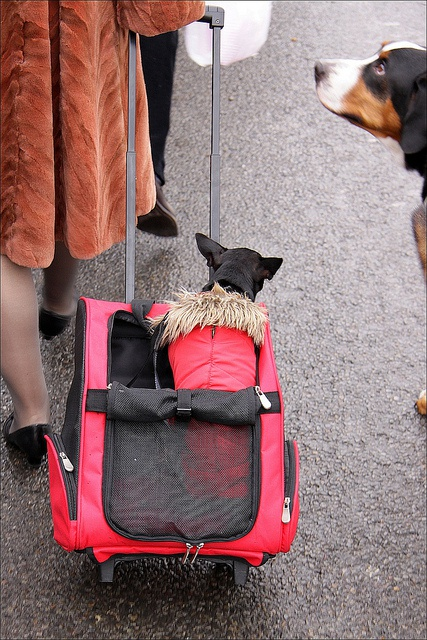Describe the objects in this image and their specific colors. I can see suitcase in black, gray, darkgray, and salmon tones, people in black, brown, and maroon tones, dog in black, gray, salmon, and brown tones, dog in black, white, gray, and tan tones, and people in black, gray, and darkgray tones in this image. 